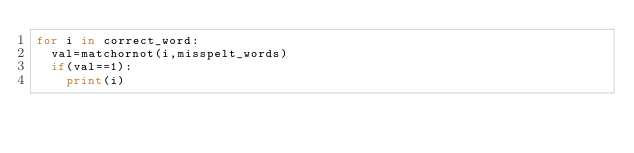<code> <loc_0><loc_0><loc_500><loc_500><_Python_>for i in correct_word:
  val=matchornot(i,misspelt_words)
  if(val==1):
    print(i)

</code> 